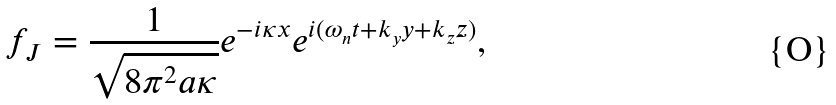Convert formula to latex. <formula><loc_0><loc_0><loc_500><loc_500>f _ { J } = \frac { 1 } { \sqrt { 8 \pi ^ { 2 } a \kappa } } e ^ { - i \kappa x } e ^ { i ( \omega _ { n } t + k _ { y } y + k _ { z } z ) } ,</formula> 